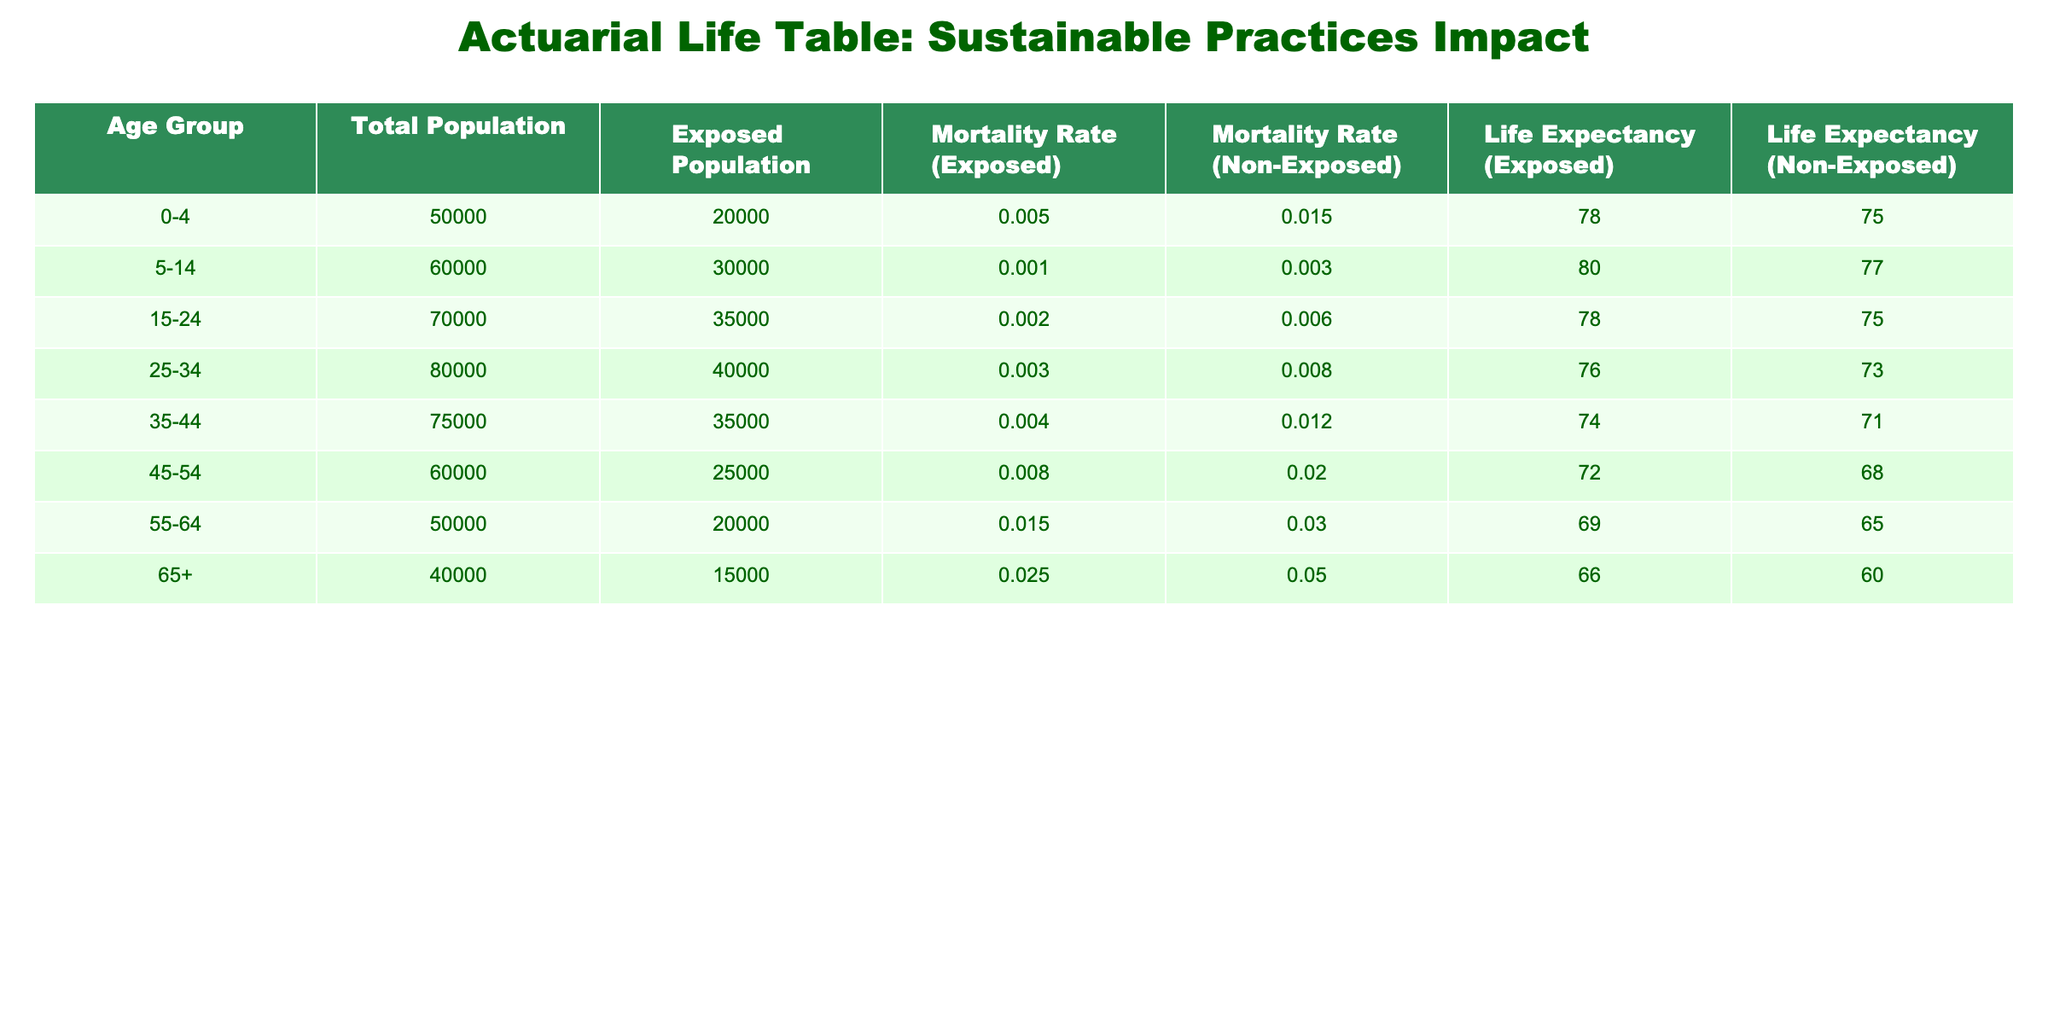What is the mortality rate for individuals aged 55-64 in the exposed population? From the table, the mortality rate for the exposed population in the age group 55-64 is listed under the column "Mortality Rate (Exposed)", which shows 0.015 or 1.5%.
Answer: 1.5% How does the life expectancy of non-exposed individuals compare to that of exposed individuals in the age group 45-54? In the table, the life expectancy for the exposed population aged 45-54 is 72 years, while for non-exposed individuals it is 68 years. The difference can be calculated as 72 - 68 = 4 years.
Answer: 4 years What is the total population of individuals aged 25-34? The total population for the age group 25-34 is directly stated in the "Total Population" column, which shows 80,000 individuals.
Answer: 80,000 Is the mortality rate for the non-exposed population higher in the age group 35-44 than in the age group 45-54? Looking at the values in the table, the mortality rate for the non-exposed population in the age group 35-44 is 0.012 or 1.2%, and for the age group 45-54 it is 0.020 or 2.0%. Since 2.0% is greater than 1.2%, the statement is true.
Answer: Yes What is the difference in life expectancy between the exposed and non-exposed populations for the age group 0-4? For the age group 0-4, the life expectancy for the exposed population is 78 years, and for the non-exposed population, it is 75 years. The difference is calculated as 78 - 75 = 3 years.
Answer: 3 years Which age group has the highest mortality rate in the exposed population? By reviewing the "Mortality Rate (Exposed)" column, we can see that the age group 65+ has the highest mortality rate of 0.025 or 2.5%.
Answer: 65+ What is the average mortality rate for the exposed populations across all age groups? To find the average, we sum the mortality rates for the exposed populations from each age group (0.005 + 0.001 + 0.002 + 0.003 + 0.004 + 0.008 + 0.015 + 0.025 = 0.058). Then, we divide by the number of age groups, which is 8. So, the average is 0.058 / 8 = 0.00725 or 0.725%.
Answer: 0.725% Is the life expectancy of the exposed population in the 65+ group greater than that of the non-exposed group? The life expectancy for the exposed population aged 65+ is 66 years, while the non-exposed group is 60 years. Since 66 is greater than 60, this statement is true.
Answer: Yes What is the total number of individuals aged 15-24 in the exposed population? The exposed population for the age group 15-24 is given directly in the "Exposed Population" column, which shows 35,000 individuals.
Answer: 35,000 